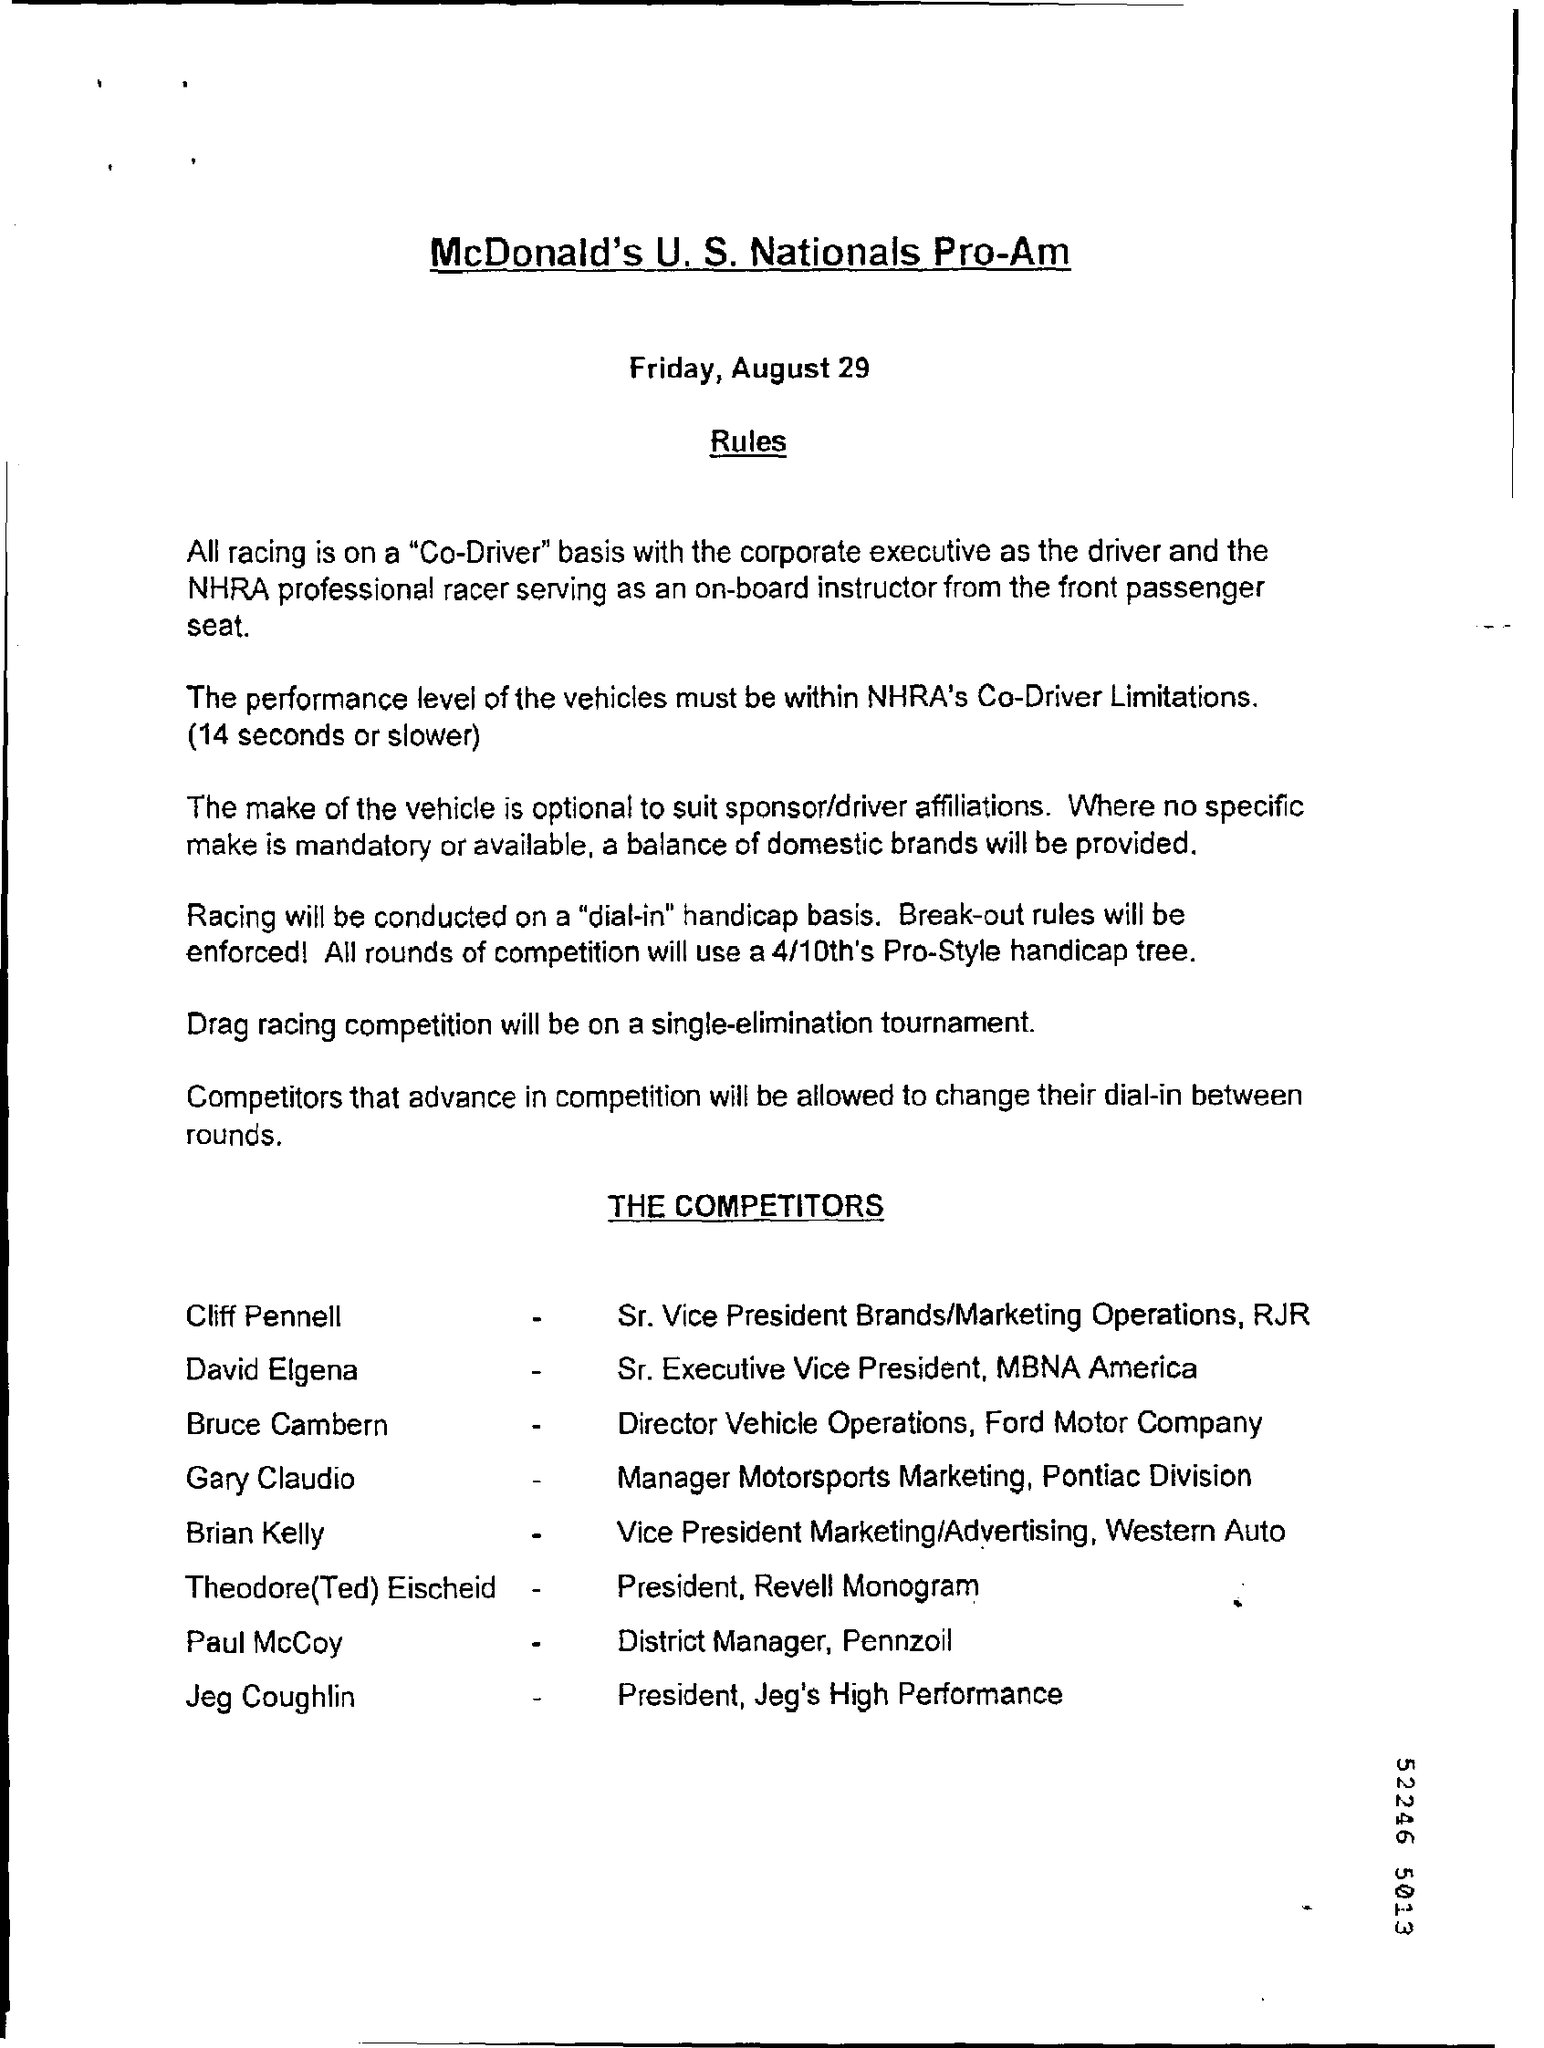Mention a couple of crucial points in this snapshot. The drag racing competition will take place in a single-elimination tournament. The date mentioned at the top is August 29. 